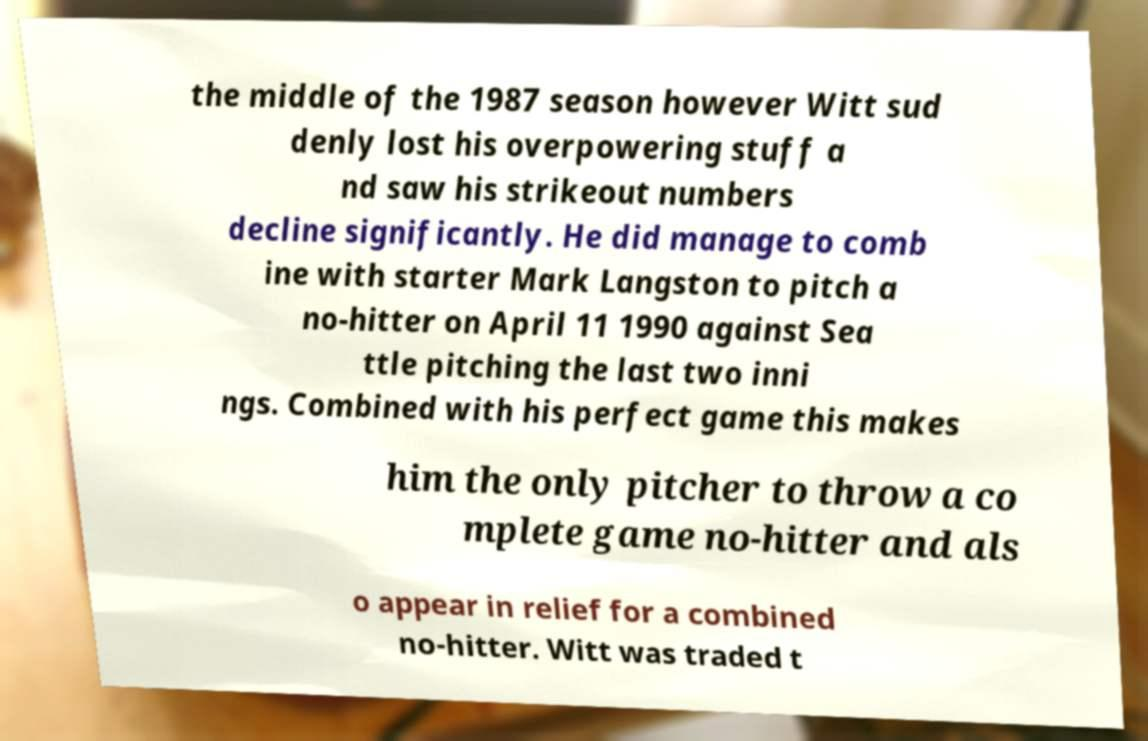Can you accurately transcribe the text from the provided image for me? the middle of the 1987 season however Witt sud denly lost his overpowering stuff a nd saw his strikeout numbers decline significantly. He did manage to comb ine with starter Mark Langston to pitch a no-hitter on April 11 1990 against Sea ttle pitching the last two inni ngs. Combined with his perfect game this makes him the only pitcher to throw a co mplete game no-hitter and als o appear in relief for a combined no-hitter. Witt was traded t 